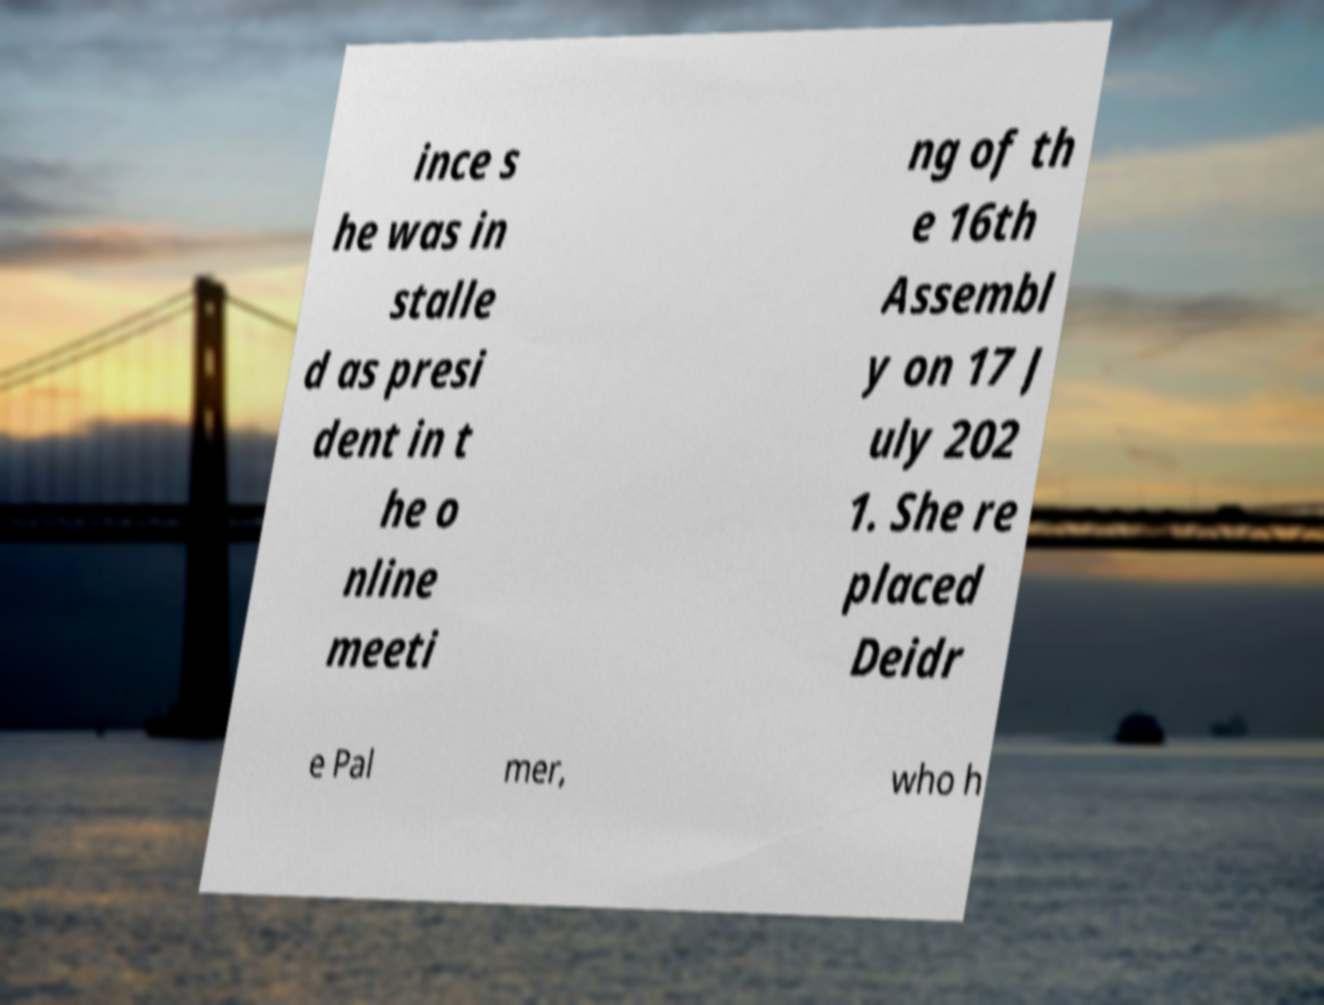Please identify and transcribe the text found in this image. ince s he was in stalle d as presi dent in t he o nline meeti ng of th e 16th Assembl y on 17 J uly 202 1. She re placed Deidr e Pal mer, who h 